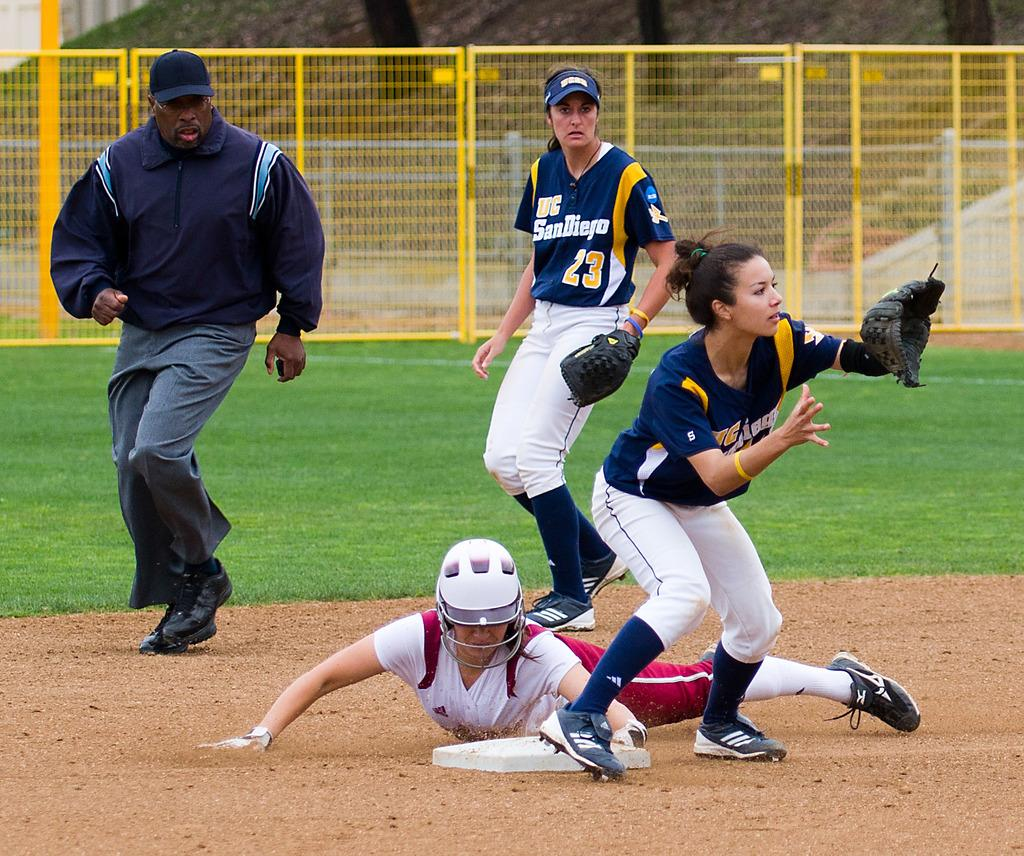<image>
Relay a brief, clear account of the picture shown. Baseball players are in a game and one players shirt reads "UC SanDiego." 